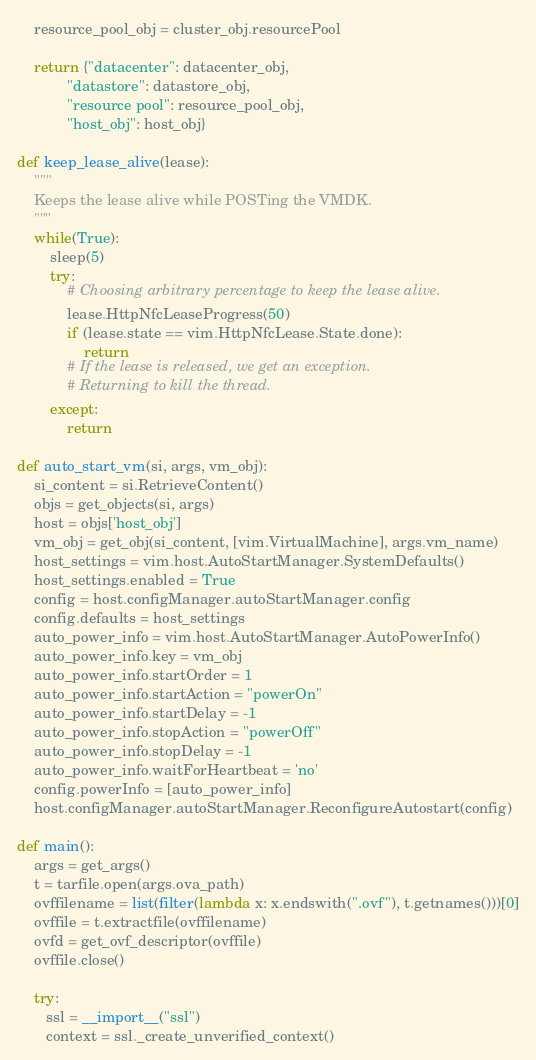Convert code to text. <code><loc_0><loc_0><loc_500><loc_500><_Python_>    resource_pool_obj = cluster_obj.resourcePool

    return {"datacenter": datacenter_obj,
            "datastore": datastore_obj,
            "resource pool": resource_pool_obj,
            "host_obj": host_obj}

def keep_lease_alive(lease):
    """
    Keeps the lease alive while POSTing the VMDK.
    """
    while(True):
        sleep(5)
        try:
            # Choosing arbitrary percentage to keep the lease alive.
            lease.HttpNfcLeaseProgress(50)
            if (lease.state == vim.HttpNfcLease.State.done):
                return
            # If the lease is released, we get an exception.
            # Returning to kill the thread.
        except:
            return

def auto_start_vm(si, args, vm_obj):
    si_content = si.RetrieveContent()
    objs = get_objects(si, args)
    host = objs['host_obj']
    vm_obj = get_obj(si_content, [vim.VirtualMachine], args.vm_name)
    host_settings = vim.host.AutoStartManager.SystemDefaults()
    host_settings.enabled = True
    config = host.configManager.autoStartManager.config
    config.defaults = host_settings
    auto_power_info = vim.host.AutoStartManager.AutoPowerInfo()
    auto_power_info.key = vm_obj
    auto_power_info.startOrder = 1
    auto_power_info.startAction = "powerOn"
    auto_power_info.startDelay = -1
    auto_power_info.stopAction = "powerOff"
    auto_power_info.stopDelay = -1
    auto_power_info.waitForHeartbeat = 'no'
    config.powerInfo = [auto_power_info]
    host.configManager.autoStartManager.ReconfigureAutostart(config)

def main():
    args = get_args()
    t = tarfile.open(args.ova_path)
    ovffilename = list(filter(lambda x: x.endswith(".ovf"), t.getnames()))[0]
    ovffile = t.extractfile(ovffilename)
    ovfd = get_ovf_descriptor(ovffile)
    ovffile.close()

    try:
       ssl = __import__("ssl")
       context = ssl._create_unverified_context()
</code> 